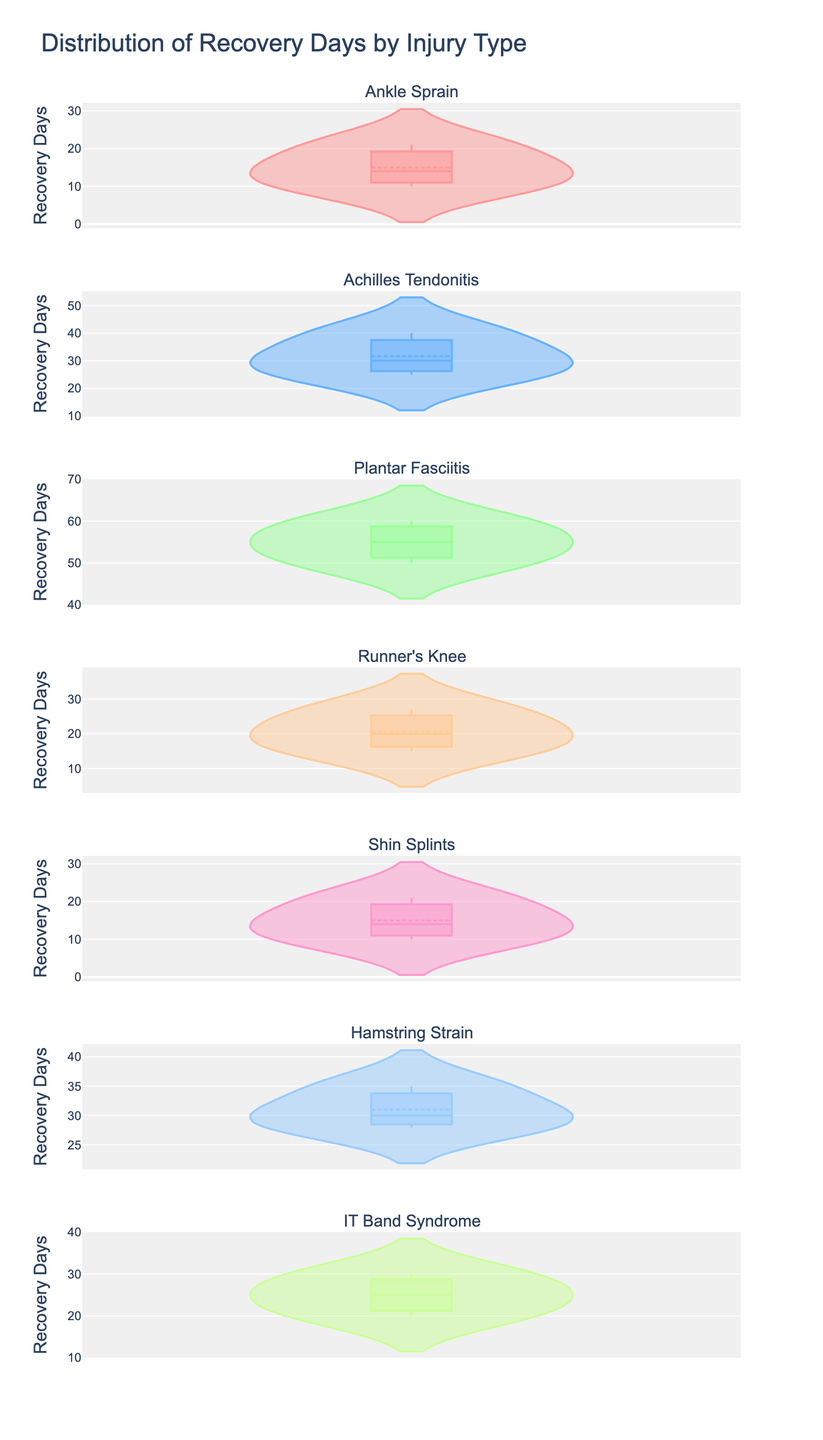What is the title of the figure? The title can be found at the top of the figure. It provides a summary of what the figure is about.
Answer: Distribution of Recovery Days by Injury Type How many injury types are displayed in the figure? Count the number of subplot titles, each representing a different injury type.
Answer: 7 Which injury type has the highest mean recovery days? Identify the mean lines in each subplot and compare their positions.
Answer: Plantar Fasciitis What is the range of recovery days for Ankle Sprain? Observe the range along the y-axis for the Ankle Sprain subplot.
Answer: 10 to 21 days Which injury type has the smallest range of recovery days? Compare the ranges for each injury type. Identify the one with the shortest span on the y-axis.
Answer: IT Band Syndrome Which injury type has the most variability in recovery days? Look for the subplot with the widest spread of data points around the mean line.
Answer: Plantar Fasciitis Compare the median recovery days of Achilles Tendonitis and Runner's Knee. Which is higher? Identify the median lines in the box plots for both types and compare their positions.
Answer: Achilles Tendonitis What is the median recovery time for Hamstring Strain? Find the median line in the Hamstring Strain subplot. It is typically located inside the box.
Answer: 30 days For Shin Splints, are the majority of recovery days above or below 15 days? Examine the distribution of data points around the 15-day mark on the y-axis for the Shin Splints subplot.
Answer: Above Is there any injury type with a recovery time consistently above 40 days? Look for any subplot where all data points are above the 40-day mark.
Answer: No 